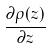<formula> <loc_0><loc_0><loc_500><loc_500>\frac { \partial \rho ( z ) } { \partial z }</formula> 